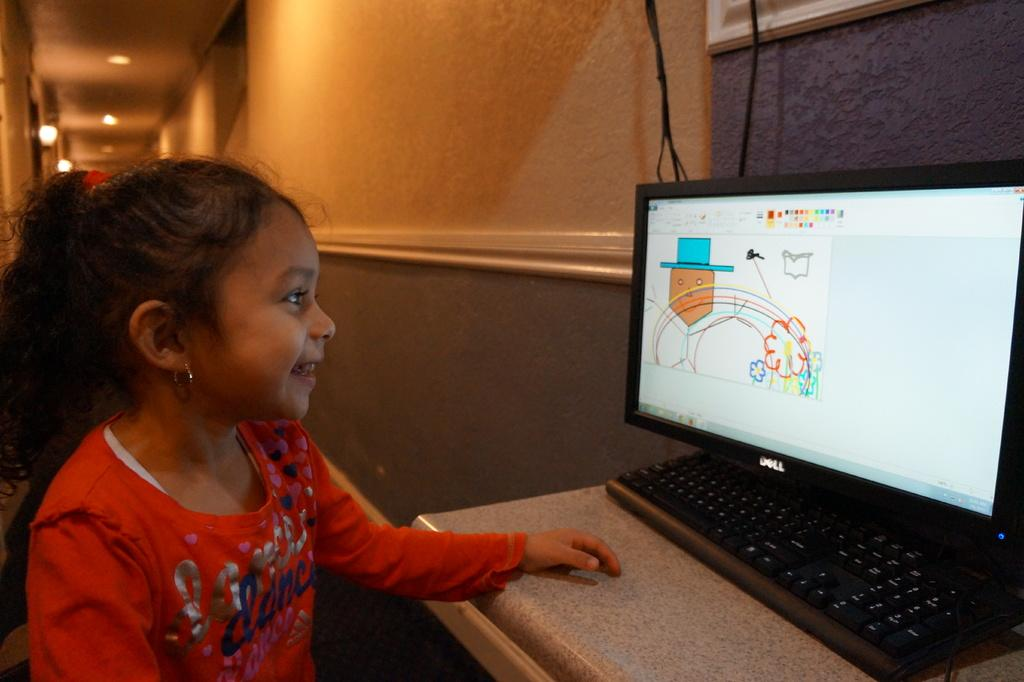Provide a one-sentence caption for the provided image. a girl with a red shirt reading DANCE looking at a computer monitor. 